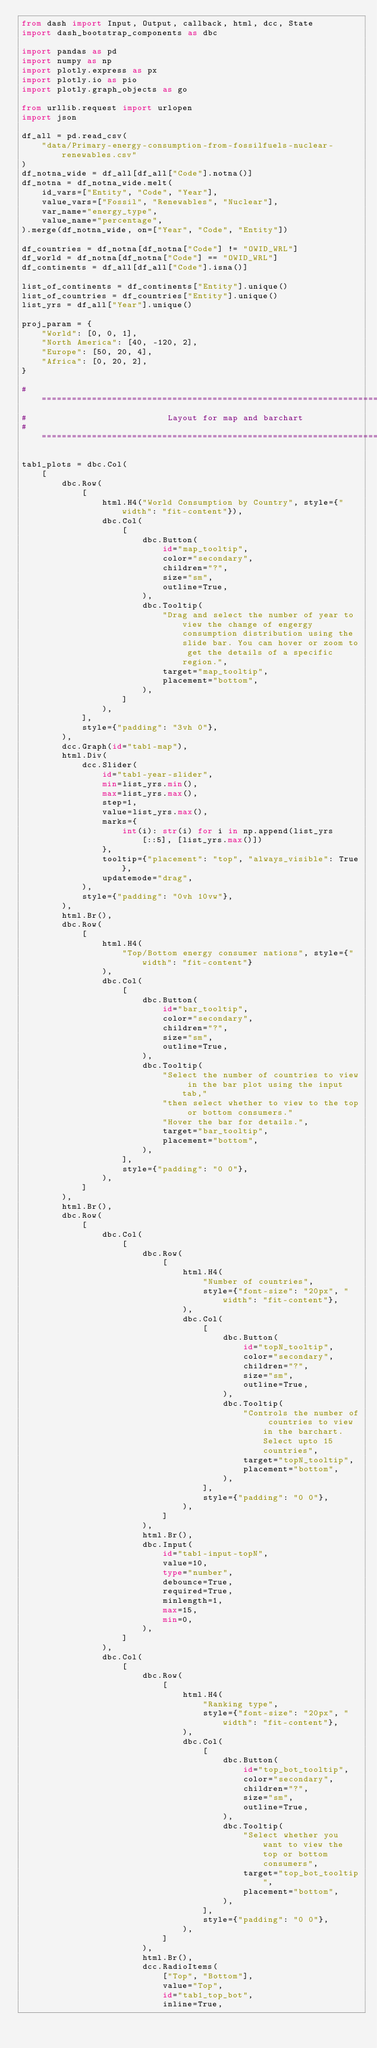<code> <loc_0><loc_0><loc_500><loc_500><_Python_>from dash import Input, Output, callback, html, dcc, State
import dash_bootstrap_components as dbc

import pandas as pd
import numpy as np
import plotly.express as px
import plotly.io as pio
import plotly.graph_objects as go

from urllib.request import urlopen
import json

df_all = pd.read_csv(
    "data/Primary-energy-consumption-from-fossilfuels-nuclear-renewables.csv"
)
df_notna_wide = df_all[df_all["Code"].notna()]
df_notna = df_notna_wide.melt(
    id_vars=["Entity", "Code", "Year"],
    value_vars=["Fossil", "Renewables", "Nuclear"],
    var_name="energy_type",
    value_name="percentage",
).merge(df_notna_wide, on=["Year", "Code", "Entity"])

df_countries = df_notna[df_notna["Code"] != "OWID_WRL"]
df_world = df_notna[df_notna["Code"] == "OWID_WRL"]
df_continents = df_all[df_all["Code"].isna()]

list_of_continents = df_continents["Entity"].unique()
list_of_countries = df_countries["Entity"].unique()
list_yrs = df_all["Year"].unique()

proj_param = {
    "World": [0, 0, 1],
    "North America": [40, -120, 2],
    "Europe": [50, 20, 4],
    "Africa": [0, 20, 2],
}

# ==============================================================================
#                            Layout for map and barchart
# ==============================================================================

tab1_plots = dbc.Col(
    [
        dbc.Row(
            [
                html.H4("World Consumption by Country", style={"width": "fit-content"}),
                dbc.Col(
                    [
                        dbc.Button(
                            id="map_tooltip",
                            color="secondary",
                            children="?",
                            size="sm",
                            outline=True,
                        ),
                        dbc.Tooltip(
                            "Drag and select the number of year to view the change of engergy consumption distribution using the slide bar. You can hover or zoom to get the details of a specific region.",
                            target="map_tooltip",
                            placement="bottom",
                        ),
                    ]
                ),
            ],
            style={"padding": "3vh 0"},
        ),
        dcc.Graph(id="tab1-map"),
        html.Div(
            dcc.Slider(
                id="tab1-year-slider",
                min=list_yrs.min(),
                max=list_yrs.max(),
                step=1,
                value=list_yrs.max(),
                marks={
                    int(i): str(i) for i in np.append(list_yrs[::5], [list_yrs.max()])
                },
                tooltip={"placement": "top", "always_visible": True},
                updatemode="drag",
            ),
            style={"padding": "0vh 10vw"},
        ),
        html.Br(),
        dbc.Row(
            [
                html.H4(
                    "Top/Bottom energy consumer nations", style={"width": "fit-content"}
                ),
                dbc.Col(
                    [
                        dbc.Button(
                            id="bar_tooltip",
                            color="secondary",
                            children="?",
                            size="sm",
                            outline=True,
                        ),
                        dbc.Tooltip(
                            "Select the number of countries to view in the bar plot using the input tab,"
                            "then select whether to view to the top or bottom consumers."
                            "Hover the bar for details.",
                            target="bar_tooltip",
                            placement="bottom",
                        ),
                    ],
                    style={"padding": "0 0"},
                ),
            ]
        ),
        html.Br(),
        dbc.Row(
            [
                dbc.Col(
                    [
                        dbc.Row(
                            [
                                html.H4(
                                    "Number of countries",
                                    style={"font-size": "20px", "width": "fit-content"},
                                ),
                                dbc.Col(
                                    [
                                        dbc.Button(
                                            id="topN_tooltip",
                                            color="secondary",
                                            children="?",
                                            size="sm",
                                            outline=True,
                                        ),
                                        dbc.Tooltip(
                                            "Controls the number of countries to view in the barchart. Select upto 15 countries",
                                            target="topN_tooltip",
                                            placement="bottom",
                                        ),
                                    ],
                                    style={"padding": "0 0"},
                                ),
                            ]
                        ),
                        html.Br(),
                        dbc.Input(
                            id="tab1-input-topN",
                            value=10,
                            type="number",
                            debounce=True,
                            required=True,
                            minlength=1,
                            max=15,
                            min=0,
                        ),
                    ]
                ),
                dbc.Col(
                    [
                        dbc.Row(
                            [
                                html.H4(
                                    "Ranking type",
                                    style={"font-size": "20px", "width": "fit-content"},
                                ),
                                dbc.Col(
                                    [
                                        dbc.Button(
                                            id="top_bot_tooltip",
                                            color="secondary",
                                            children="?",
                                            size="sm",
                                            outline=True,
                                        ),
                                        dbc.Tooltip(
                                            "Select whether you want to view the top or bottom consumers",
                                            target="top_bot_tooltip",
                                            placement="bottom",
                                        ),
                                    ],
                                    style={"padding": "0 0"},
                                ),
                            ]
                        ),
                        html.Br(),
                        dcc.RadioItems(
                            ["Top", "Bottom"],
                            value="Top",
                            id="tab1_top_bot",
                            inline=True,</code> 